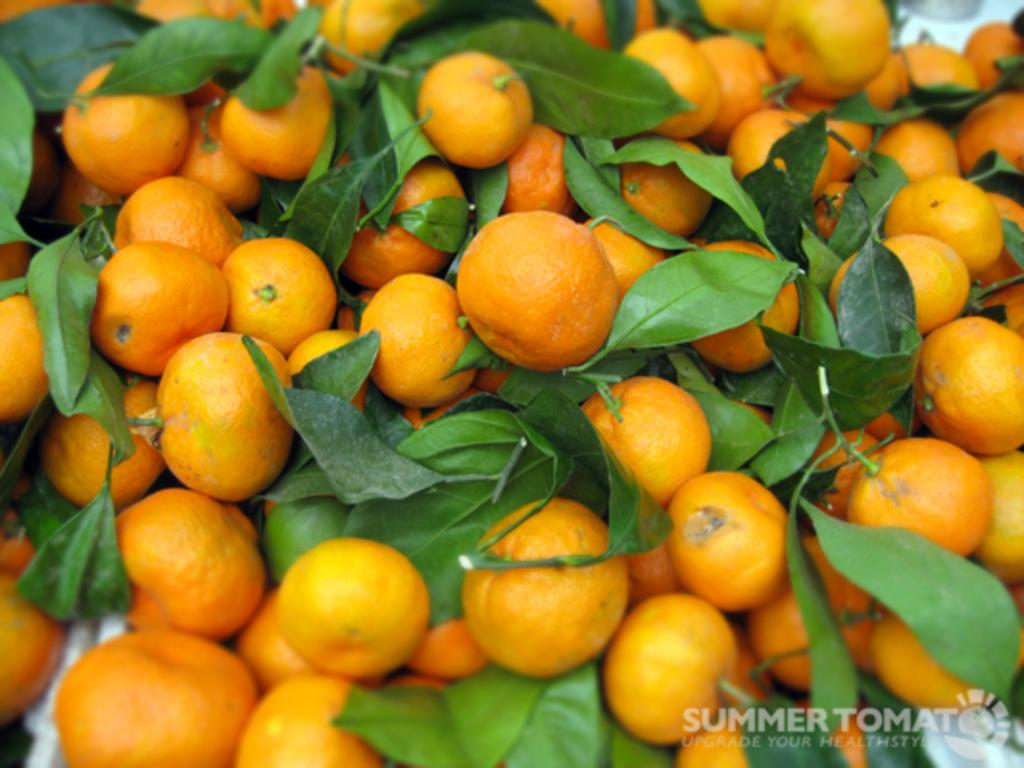What type of food can be seen in the image? There are fruits in the image. What else is present in the image besides the fruits? There are leaves in the image. What type of fly can be seen on the fruits in the image? There are no flies present in the image; it only features fruits and leaves. What form of transportation does the aunt use to visit in the image? There is no mention of an aunt or any form of transportation in the image. 